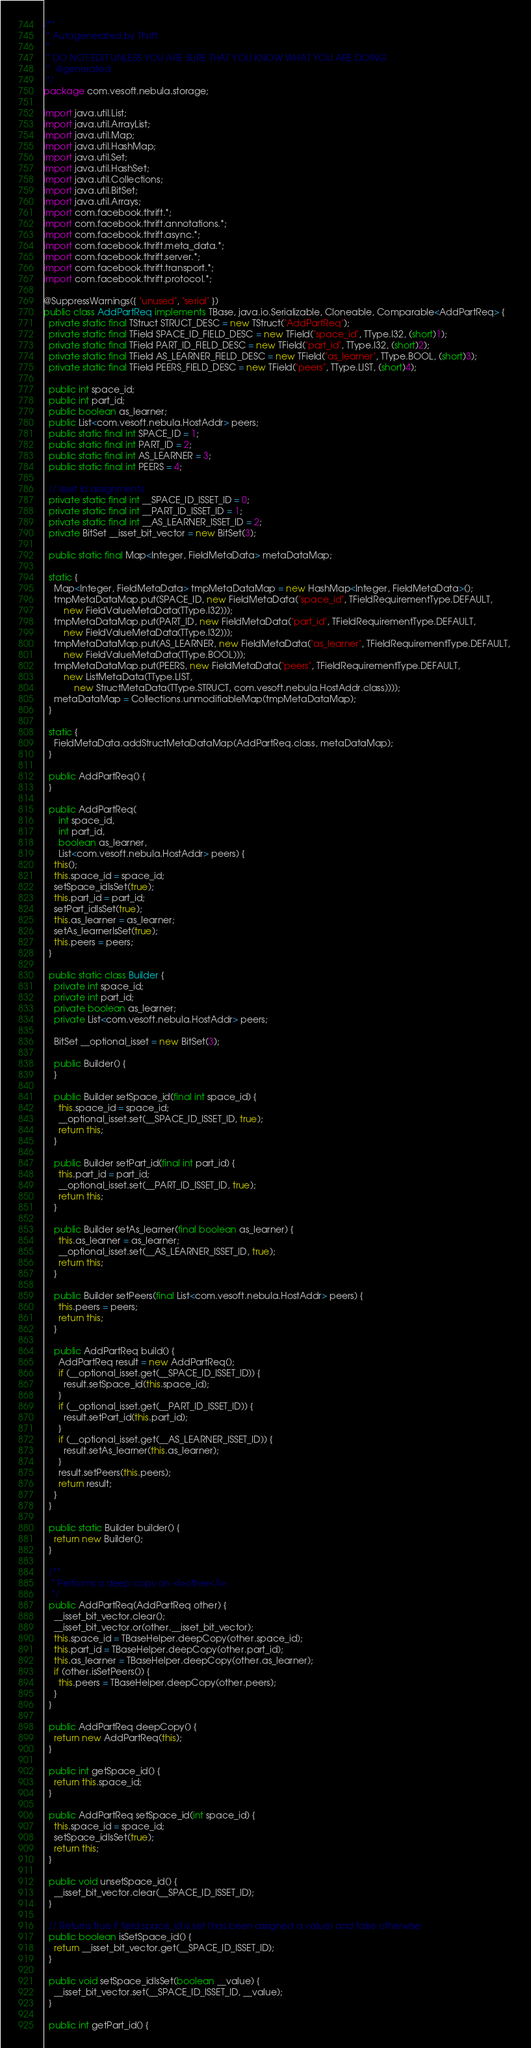<code> <loc_0><loc_0><loc_500><loc_500><_Java_>/**
 * Autogenerated by Thrift
 *
 * DO NOT EDIT UNLESS YOU ARE SURE THAT YOU KNOW WHAT YOU ARE DOING
 *  @generated
 */
package com.vesoft.nebula.storage;

import java.util.List;
import java.util.ArrayList;
import java.util.Map;
import java.util.HashMap;
import java.util.Set;
import java.util.HashSet;
import java.util.Collections;
import java.util.BitSet;
import java.util.Arrays;
import com.facebook.thrift.*;
import com.facebook.thrift.annotations.*;
import com.facebook.thrift.async.*;
import com.facebook.thrift.meta_data.*;
import com.facebook.thrift.server.*;
import com.facebook.thrift.transport.*;
import com.facebook.thrift.protocol.*;

@SuppressWarnings({ "unused", "serial" })
public class AddPartReq implements TBase, java.io.Serializable, Cloneable, Comparable<AddPartReq> {
  private static final TStruct STRUCT_DESC = new TStruct("AddPartReq");
  private static final TField SPACE_ID_FIELD_DESC = new TField("space_id", TType.I32, (short)1);
  private static final TField PART_ID_FIELD_DESC = new TField("part_id", TType.I32, (short)2);
  private static final TField AS_LEARNER_FIELD_DESC = new TField("as_learner", TType.BOOL, (short)3);
  private static final TField PEERS_FIELD_DESC = new TField("peers", TType.LIST, (short)4);

  public int space_id;
  public int part_id;
  public boolean as_learner;
  public List<com.vesoft.nebula.HostAddr> peers;
  public static final int SPACE_ID = 1;
  public static final int PART_ID = 2;
  public static final int AS_LEARNER = 3;
  public static final int PEERS = 4;

  // isset id assignments
  private static final int __SPACE_ID_ISSET_ID = 0;
  private static final int __PART_ID_ISSET_ID = 1;
  private static final int __AS_LEARNER_ISSET_ID = 2;
  private BitSet __isset_bit_vector = new BitSet(3);

  public static final Map<Integer, FieldMetaData> metaDataMap;

  static {
    Map<Integer, FieldMetaData> tmpMetaDataMap = new HashMap<Integer, FieldMetaData>();
    tmpMetaDataMap.put(SPACE_ID, new FieldMetaData("space_id", TFieldRequirementType.DEFAULT, 
        new FieldValueMetaData(TType.I32)));
    tmpMetaDataMap.put(PART_ID, new FieldMetaData("part_id", TFieldRequirementType.DEFAULT, 
        new FieldValueMetaData(TType.I32)));
    tmpMetaDataMap.put(AS_LEARNER, new FieldMetaData("as_learner", TFieldRequirementType.DEFAULT, 
        new FieldValueMetaData(TType.BOOL)));
    tmpMetaDataMap.put(PEERS, new FieldMetaData("peers", TFieldRequirementType.DEFAULT, 
        new ListMetaData(TType.LIST, 
            new StructMetaData(TType.STRUCT, com.vesoft.nebula.HostAddr.class))));
    metaDataMap = Collections.unmodifiableMap(tmpMetaDataMap);
  }

  static {
    FieldMetaData.addStructMetaDataMap(AddPartReq.class, metaDataMap);
  }

  public AddPartReq() {
  }

  public AddPartReq(
      int space_id,
      int part_id,
      boolean as_learner,
      List<com.vesoft.nebula.HostAddr> peers) {
    this();
    this.space_id = space_id;
    setSpace_idIsSet(true);
    this.part_id = part_id;
    setPart_idIsSet(true);
    this.as_learner = as_learner;
    setAs_learnerIsSet(true);
    this.peers = peers;
  }

  public static class Builder {
    private int space_id;
    private int part_id;
    private boolean as_learner;
    private List<com.vesoft.nebula.HostAddr> peers;

    BitSet __optional_isset = new BitSet(3);

    public Builder() {
    }

    public Builder setSpace_id(final int space_id) {
      this.space_id = space_id;
      __optional_isset.set(__SPACE_ID_ISSET_ID, true);
      return this;
    }

    public Builder setPart_id(final int part_id) {
      this.part_id = part_id;
      __optional_isset.set(__PART_ID_ISSET_ID, true);
      return this;
    }

    public Builder setAs_learner(final boolean as_learner) {
      this.as_learner = as_learner;
      __optional_isset.set(__AS_LEARNER_ISSET_ID, true);
      return this;
    }

    public Builder setPeers(final List<com.vesoft.nebula.HostAddr> peers) {
      this.peers = peers;
      return this;
    }

    public AddPartReq build() {
      AddPartReq result = new AddPartReq();
      if (__optional_isset.get(__SPACE_ID_ISSET_ID)) {
        result.setSpace_id(this.space_id);
      }
      if (__optional_isset.get(__PART_ID_ISSET_ID)) {
        result.setPart_id(this.part_id);
      }
      if (__optional_isset.get(__AS_LEARNER_ISSET_ID)) {
        result.setAs_learner(this.as_learner);
      }
      result.setPeers(this.peers);
      return result;
    }
  }

  public static Builder builder() {
    return new Builder();
  }

  /**
   * Performs a deep copy on <i>other</i>.
   */
  public AddPartReq(AddPartReq other) {
    __isset_bit_vector.clear();
    __isset_bit_vector.or(other.__isset_bit_vector);
    this.space_id = TBaseHelper.deepCopy(other.space_id);
    this.part_id = TBaseHelper.deepCopy(other.part_id);
    this.as_learner = TBaseHelper.deepCopy(other.as_learner);
    if (other.isSetPeers()) {
      this.peers = TBaseHelper.deepCopy(other.peers);
    }
  }

  public AddPartReq deepCopy() {
    return new AddPartReq(this);
  }

  public int getSpace_id() {
    return this.space_id;
  }

  public AddPartReq setSpace_id(int space_id) {
    this.space_id = space_id;
    setSpace_idIsSet(true);
    return this;
  }

  public void unsetSpace_id() {
    __isset_bit_vector.clear(__SPACE_ID_ISSET_ID);
  }

  // Returns true if field space_id is set (has been assigned a value) and false otherwise
  public boolean isSetSpace_id() {
    return __isset_bit_vector.get(__SPACE_ID_ISSET_ID);
  }

  public void setSpace_idIsSet(boolean __value) {
    __isset_bit_vector.set(__SPACE_ID_ISSET_ID, __value);
  }

  public int getPart_id() {</code> 